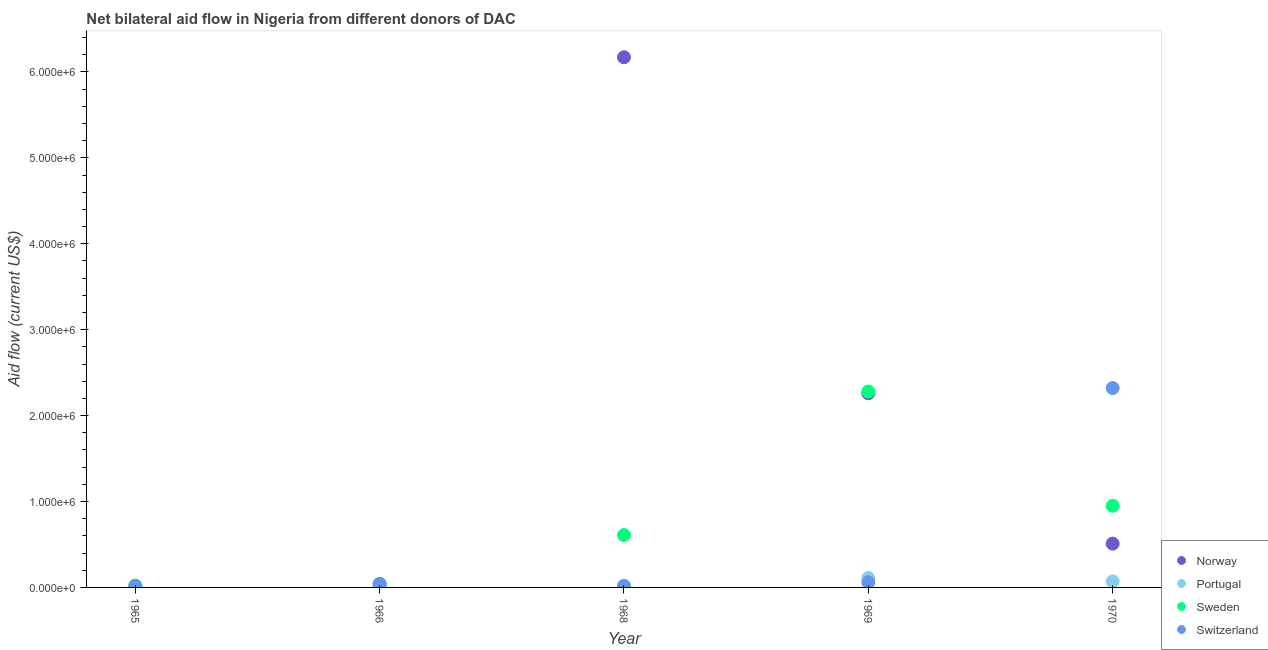How many different coloured dotlines are there?
Make the answer very short. 4. Is the number of dotlines equal to the number of legend labels?
Offer a very short reply. Yes. What is the amount of aid given by norway in 1966?
Give a very brief answer. 4.00e+04. Across all years, what is the maximum amount of aid given by portugal?
Make the answer very short. 1.10e+05. Across all years, what is the minimum amount of aid given by sweden?
Your answer should be compact. 10000. In which year was the amount of aid given by portugal maximum?
Keep it short and to the point. 1969. In which year was the amount of aid given by portugal minimum?
Offer a very short reply. 1965. What is the total amount of aid given by sweden in the graph?
Keep it short and to the point. 3.86e+06. What is the difference between the amount of aid given by portugal in 1969 and that in 1970?
Ensure brevity in your answer.  4.00e+04. What is the difference between the amount of aid given by sweden in 1969 and the amount of aid given by switzerland in 1968?
Keep it short and to the point. 2.26e+06. What is the average amount of aid given by switzerland per year?
Keep it short and to the point. 4.90e+05. In the year 1970, what is the difference between the amount of aid given by norway and amount of aid given by switzerland?
Keep it short and to the point. -1.81e+06. In how many years, is the amount of aid given by sweden greater than 5800000 US$?
Your answer should be very brief. 0. What is the ratio of the amount of aid given by switzerland in 1966 to that in 1969?
Provide a short and direct response. 0.67. Is the amount of aid given by switzerland in 1965 less than that in 1966?
Give a very brief answer. Yes. Is the difference between the amount of aid given by switzerland in 1965 and 1970 greater than the difference between the amount of aid given by norway in 1965 and 1970?
Ensure brevity in your answer.  No. What is the difference between the highest and the second highest amount of aid given by norway?
Your answer should be very brief. 3.91e+06. What is the difference between the highest and the lowest amount of aid given by switzerland?
Give a very brief answer. 2.31e+06. In how many years, is the amount of aid given by sweden greater than the average amount of aid given by sweden taken over all years?
Ensure brevity in your answer.  2. Is the sum of the amount of aid given by portugal in 1965 and 1966 greater than the maximum amount of aid given by sweden across all years?
Keep it short and to the point. No. Is the amount of aid given by switzerland strictly greater than the amount of aid given by norway over the years?
Provide a succinct answer. No. Is the amount of aid given by norway strictly less than the amount of aid given by sweden over the years?
Your response must be concise. No. What is the difference between two consecutive major ticks on the Y-axis?
Make the answer very short. 1.00e+06. Are the values on the major ticks of Y-axis written in scientific E-notation?
Make the answer very short. Yes. Does the graph contain grids?
Offer a terse response. No. Where does the legend appear in the graph?
Give a very brief answer. Bottom right. What is the title of the graph?
Make the answer very short. Net bilateral aid flow in Nigeria from different donors of DAC. What is the Aid flow (current US$) of Portugal in 1965?
Keep it short and to the point. 10000. What is the Aid flow (current US$) in Switzerland in 1965?
Your answer should be compact. 10000. What is the Aid flow (current US$) of Switzerland in 1966?
Make the answer very short. 4.00e+04. What is the Aid flow (current US$) in Norway in 1968?
Provide a succinct answer. 6.17e+06. What is the Aid flow (current US$) of Sweden in 1968?
Keep it short and to the point. 6.10e+05. What is the Aid flow (current US$) of Switzerland in 1968?
Offer a very short reply. 2.00e+04. What is the Aid flow (current US$) in Norway in 1969?
Provide a short and direct response. 2.26e+06. What is the Aid flow (current US$) of Portugal in 1969?
Offer a terse response. 1.10e+05. What is the Aid flow (current US$) in Sweden in 1969?
Offer a terse response. 2.28e+06. What is the Aid flow (current US$) in Norway in 1970?
Your response must be concise. 5.10e+05. What is the Aid flow (current US$) of Sweden in 1970?
Provide a succinct answer. 9.50e+05. What is the Aid flow (current US$) of Switzerland in 1970?
Provide a succinct answer. 2.32e+06. Across all years, what is the maximum Aid flow (current US$) in Norway?
Your answer should be very brief. 6.17e+06. Across all years, what is the maximum Aid flow (current US$) of Portugal?
Provide a short and direct response. 1.10e+05. Across all years, what is the maximum Aid flow (current US$) in Sweden?
Give a very brief answer. 2.28e+06. Across all years, what is the maximum Aid flow (current US$) in Switzerland?
Give a very brief answer. 2.32e+06. Across all years, what is the minimum Aid flow (current US$) of Norway?
Your answer should be very brief. 2.00e+04. What is the total Aid flow (current US$) of Norway in the graph?
Ensure brevity in your answer.  9.00e+06. What is the total Aid flow (current US$) in Sweden in the graph?
Provide a succinct answer. 3.86e+06. What is the total Aid flow (current US$) in Switzerland in the graph?
Offer a terse response. 2.45e+06. What is the difference between the Aid flow (current US$) in Sweden in 1965 and that in 1966?
Make the answer very short. 0. What is the difference between the Aid flow (current US$) of Norway in 1965 and that in 1968?
Provide a succinct answer. -6.15e+06. What is the difference between the Aid flow (current US$) in Portugal in 1965 and that in 1968?
Make the answer very short. 0. What is the difference between the Aid flow (current US$) of Sweden in 1965 and that in 1968?
Keep it short and to the point. -6.00e+05. What is the difference between the Aid flow (current US$) in Switzerland in 1965 and that in 1968?
Offer a terse response. -10000. What is the difference between the Aid flow (current US$) of Norway in 1965 and that in 1969?
Make the answer very short. -2.24e+06. What is the difference between the Aid flow (current US$) in Portugal in 1965 and that in 1969?
Provide a succinct answer. -1.00e+05. What is the difference between the Aid flow (current US$) of Sweden in 1965 and that in 1969?
Your response must be concise. -2.27e+06. What is the difference between the Aid flow (current US$) of Norway in 1965 and that in 1970?
Your response must be concise. -4.90e+05. What is the difference between the Aid flow (current US$) of Sweden in 1965 and that in 1970?
Ensure brevity in your answer.  -9.40e+05. What is the difference between the Aid flow (current US$) of Switzerland in 1965 and that in 1970?
Give a very brief answer. -2.31e+06. What is the difference between the Aid flow (current US$) of Norway in 1966 and that in 1968?
Make the answer very short. -6.13e+06. What is the difference between the Aid flow (current US$) in Sweden in 1966 and that in 1968?
Your answer should be very brief. -6.00e+05. What is the difference between the Aid flow (current US$) of Switzerland in 1966 and that in 1968?
Ensure brevity in your answer.  2.00e+04. What is the difference between the Aid flow (current US$) of Norway in 1966 and that in 1969?
Give a very brief answer. -2.22e+06. What is the difference between the Aid flow (current US$) in Sweden in 1966 and that in 1969?
Offer a terse response. -2.27e+06. What is the difference between the Aid flow (current US$) in Switzerland in 1966 and that in 1969?
Your response must be concise. -2.00e+04. What is the difference between the Aid flow (current US$) in Norway in 1966 and that in 1970?
Make the answer very short. -4.70e+05. What is the difference between the Aid flow (current US$) of Portugal in 1966 and that in 1970?
Your response must be concise. -6.00e+04. What is the difference between the Aid flow (current US$) of Sweden in 1966 and that in 1970?
Offer a very short reply. -9.40e+05. What is the difference between the Aid flow (current US$) in Switzerland in 1966 and that in 1970?
Your answer should be very brief. -2.28e+06. What is the difference between the Aid flow (current US$) in Norway in 1968 and that in 1969?
Provide a short and direct response. 3.91e+06. What is the difference between the Aid flow (current US$) in Sweden in 1968 and that in 1969?
Offer a terse response. -1.67e+06. What is the difference between the Aid flow (current US$) in Switzerland in 1968 and that in 1969?
Provide a short and direct response. -4.00e+04. What is the difference between the Aid flow (current US$) of Norway in 1968 and that in 1970?
Provide a short and direct response. 5.66e+06. What is the difference between the Aid flow (current US$) in Portugal in 1968 and that in 1970?
Keep it short and to the point. -6.00e+04. What is the difference between the Aid flow (current US$) of Switzerland in 1968 and that in 1970?
Offer a very short reply. -2.30e+06. What is the difference between the Aid flow (current US$) of Norway in 1969 and that in 1970?
Make the answer very short. 1.75e+06. What is the difference between the Aid flow (current US$) of Portugal in 1969 and that in 1970?
Your response must be concise. 4.00e+04. What is the difference between the Aid flow (current US$) in Sweden in 1969 and that in 1970?
Give a very brief answer. 1.33e+06. What is the difference between the Aid flow (current US$) of Switzerland in 1969 and that in 1970?
Your answer should be compact. -2.26e+06. What is the difference between the Aid flow (current US$) in Norway in 1965 and the Aid flow (current US$) in Portugal in 1966?
Ensure brevity in your answer.  10000. What is the difference between the Aid flow (current US$) in Norway in 1965 and the Aid flow (current US$) in Switzerland in 1966?
Offer a very short reply. -2.00e+04. What is the difference between the Aid flow (current US$) of Sweden in 1965 and the Aid flow (current US$) of Switzerland in 1966?
Provide a succinct answer. -3.00e+04. What is the difference between the Aid flow (current US$) of Norway in 1965 and the Aid flow (current US$) of Portugal in 1968?
Provide a short and direct response. 10000. What is the difference between the Aid flow (current US$) in Norway in 1965 and the Aid flow (current US$) in Sweden in 1968?
Ensure brevity in your answer.  -5.90e+05. What is the difference between the Aid flow (current US$) of Portugal in 1965 and the Aid flow (current US$) of Sweden in 1968?
Your response must be concise. -6.00e+05. What is the difference between the Aid flow (current US$) of Portugal in 1965 and the Aid flow (current US$) of Switzerland in 1968?
Offer a terse response. -10000. What is the difference between the Aid flow (current US$) of Sweden in 1965 and the Aid flow (current US$) of Switzerland in 1968?
Make the answer very short. -10000. What is the difference between the Aid flow (current US$) in Norway in 1965 and the Aid flow (current US$) in Portugal in 1969?
Your answer should be very brief. -9.00e+04. What is the difference between the Aid flow (current US$) of Norway in 1965 and the Aid flow (current US$) of Sweden in 1969?
Offer a terse response. -2.26e+06. What is the difference between the Aid flow (current US$) in Norway in 1965 and the Aid flow (current US$) in Switzerland in 1969?
Keep it short and to the point. -4.00e+04. What is the difference between the Aid flow (current US$) in Portugal in 1965 and the Aid flow (current US$) in Sweden in 1969?
Offer a very short reply. -2.27e+06. What is the difference between the Aid flow (current US$) in Norway in 1965 and the Aid flow (current US$) in Portugal in 1970?
Offer a terse response. -5.00e+04. What is the difference between the Aid flow (current US$) of Norway in 1965 and the Aid flow (current US$) of Sweden in 1970?
Your response must be concise. -9.30e+05. What is the difference between the Aid flow (current US$) in Norway in 1965 and the Aid flow (current US$) in Switzerland in 1970?
Your answer should be compact. -2.30e+06. What is the difference between the Aid flow (current US$) in Portugal in 1965 and the Aid flow (current US$) in Sweden in 1970?
Make the answer very short. -9.40e+05. What is the difference between the Aid flow (current US$) in Portugal in 1965 and the Aid flow (current US$) in Switzerland in 1970?
Your answer should be compact. -2.31e+06. What is the difference between the Aid flow (current US$) of Sweden in 1965 and the Aid flow (current US$) of Switzerland in 1970?
Give a very brief answer. -2.31e+06. What is the difference between the Aid flow (current US$) of Norway in 1966 and the Aid flow (current US$) of Sweden in 1968?
Your answer should be very brief. -5.70e+05. What is the difference between the Aid flow (current US$) of Portugal in 1966 and the Aid flow (current US$) of Sweden in 1968?
Your answer should be compact. -6.00e+05. What is the difference between the Aid flow (current US$) of Sweden in 1966 and the Aid flow (current US$) of Switzerland in 1968?
Give a very brief answer. -10000. What is the difference between the Aid flow (current US$) of Norway in 1966 and the Aid flow (current US$) of Sweden in 1969?
Offer a terse response. -2.24e+06. What is the difference between the Aid flow (current US$) of Portugal in 1966 and the Aid flow (current US$) of Sweden in 1969?
Provide a short and direct response. -2.27e+06. What is the difference between the Aid flow (current US$) of Sweden in 1966 and the Aid flow (current US$) of Switzerland in 1969?
Your answer should be very brief. -5.00e+04. What is the difference between the Aid flow (current US$) of Norway in 1966 and the Aid flow (current US$) of Sweden in 1970?
Provide a short and direct response. -9.10e+05. What is the difference between the Aid flow (current US$) in Norway in 1966 and the Aid flow (current US$) in Switzerland in 1970?
Keep it short and to the point. -2.28e+06. What is the difference between the Aid flow (current US$) in Portugal in 1966 and the Aid flow (current US$) in Sweden in 1970?
Your response must be concise. -9.40e+05. What is the difference between the Aid flow (current US$) of Portugal in 1966 and the Aid flow (current US$) of Switzerland in 1970?
Ensure brevity in your answer.  -2.31e+06. What is the difference between the Aid flow (current US$) of Sweden in 1966 and the Aid flow (current US$) of Switzerland in 1970?
Provide a short and direct response. -2.31e+06. What is the difference between the Aid flow (current US$) of Norway in 1968 and the Aid flow (current US$) of Portugal in 1969?
Your response must be concise. 6.06e+06. What is the difference between the Aid flow (current US$) of Norway in 1968 and the Aid flow (current US$) of Sweden in 1969?
Ensure brevity in your answer.  3.89e+06. What is the difference between the Aid flow (current US$) in Norway in 1968 and the Aid flow (current US$) in Switzerland in 1969?
Offer a terse response. 6.11e+06. What is the difference between the Aid flow (current US$) in Portugal in 1968 and the Aid flow (current US$) in Sweden in 1969?
Your response must be concise. -2.27e+06. What is the difference between the Aid flow (current US$) in Portugal in 1968 and the Aid flow (current US$) in Switzerland in 1969?
Provide a succinct answer. -5.00e+04. What is the difference between the Aid flow (current US$) in Norway in 1968 and the Aid flow (current US$) in Portugal in 1970?
Make the answer very short. 6.10e+06. What is the difference between the Aid flow (current US$) in Norway in 1968 and the Aid flow (current US$) in Sweden in 1970?
Provide a short and direct response. 5.22e+06. What is the difference between the Aid flow (current US$) in Norway in 1968 and the Aid flow (current US$) in Switzerland in 1970?
Provide a short and direct response. 3.85e+06. What is the difference between the Aid flow (current US$) of Portugal in 1968 and the Aid flow (current US$) of Sweden in 1970?
Ensure brevity in your answer.  -9.40e+05. What is the difference between the Aid flow (current US$) of Portugal in 1968 and the Aid flow (current US$) of Switzerland in 1970?
Provide a succinct answer. -2.31e+06. What is the difference between the Aid flow (current US$) in Sweden in 1968 and the Aid flow (current US$) in Switzerland in 1970?
Give a very brief answer. -1.71e+06. What is the difference between the Aid flow (current US$) in Norway in 1969 and the Aid flow (current US$) in Portugal in 1970?
Provide a short and direct response. 2.19e+06. What is the difference between the Aid flow (current US$) in Norway in 1969 and the Aid flow (current US$) in Sweden in 1970?
Make the answer very short. 1.31e+06. What is the difference between the Aid flow (current US$) in Portugal in 1969 and the Aid flow (current US$) in Sweden in 1970?
Give a very brief answer. -8.40e+05. What is the difference between the Aid flow (current US$) of Portugal in 1969 and the Aid flow (current US$) of Switzerland in 1970?
Give a very brief answer. -2.21e+06. What is the average Aid flow (current US$) of Norway per year?
Your answer should be very brief. 1.80e+06. What is the average Aid flow (current US$) of Portugal per year?
Offer a very short reply. 4.20e+04. What is the average Aid flow (current US$) in Sweden per year?
Give a very brief answer. 7.72e+05. In the year 1965, what is the difference between the Aid flow (current US$) of Norway and Aid flow (current US$) of Portugal?
Keep it short and to the point. 10000. In the year 1965, what is the difference between the Aid flow (current US$) in Portugal and Aid flow (current US$) in Sweden?
Ensure brevity in your answer.  0. In the year 1965, what is the difference between the Aid flow (current US$) in Portugal and Aid flow (current US$) in Switzerland?
Offer a very short reply. 0. In the year 1965, what is the difference between the Aid flow (current US$) in Sweden and Aid flow (current US$) in Switzerland?
Offer a very short reply. 0. In the year 1966, what is the difference between the Aid flow (current US$) in Norway and Aid flow (current US$) in Portugal?
Your answer should be very brief. 3.00e+04. In the year 1966, what is the difference between the Aid flow (current US$) of Norway and Aid flow (current US$) of Sweden?
Your response must be concise. 3.00e+04. In the year 1966, what is the difference between the Aid flow (current US$) of Portugal and Aid flow (current US$) of Sweden?
Offer a very short reply. 0. In the year 1968, what is the difference between the Aid flow (current US$) in Norway and Aid flow (current US$) in Portugal?
Provide a short and direct response. 6.16e+06. In the year 1968, what is the difference between the Aid flow (current US$) in Norway and Aid flow (current US$) in Sweden?
Your answer should be compact. 5.56e+06. In the year 1968, what is the difference between the Aid flow (current US$) in Norway and Aid flow (current US$) in Switzerland?
Offer a very short reply. 6.15e+06. In the year 1968, what is the difference between the Aid flow (current US$) of Portugal and Aid flow (current US$) of Sweden?
Your answer should be very brief. -6.00e+05. In the year 1968, what is the difference between the Aid flow (current US$) in Sweden and Aid flow (current US$) in Switzerland?
Your answer should be compact. 5.90e+05. In the year 1969, what is the difference between the Aid flow (current US$) of Norway and Aid flow (current US$) of Portugal?
Give a very brief answer. 2.15e+06. In the year 1969, what is the difference between the Aid flow (current US$) of Norway and Aid flow (current US$) of Sweden?
Your answer should be compact. -2.00e+04. In the year 1969, what is the difference between the Aid flow (current US$) of Norway and Aid flow (current US$) of Switzerland?
Your answer should be very brief. 2.20e+06. In the year 1969, what is the difference between the Aid flow (current US$) of Portugal and Aid flow (current US$) of Sweden?
Keep it short and to the point. -2.17e+06. In the year 1969, what is the difference between the Aid flow (current US$) of Portugal and Aid flow (current US$) of Switzerland?
Provide a succinct answer. 5.00e+04. In the year 1969, what is the difference between the Aid flow (current US$) in Sweden and Aid flow (current US$) in Switzerland?
Offer a terse response. 2.22e+06. In the year 1970, what is the difference between the Aid flow (current US$) of Norway and Aid flow (current US$) of Sweden?
Keep it short and to the point. -4.40e+05. In the year 1970, what is the difference between the Aid flow (current US$) in Norway and Aid flow (current US$) in Switzerland?
Give a very brief answer. -1.81e+06. In the year 1970, what is the difference between the Aid flow (current US$) in Portugal and Aid flow (current US$) in Sweden?
Offer a terse response. -8.80e+05. In the year 1970, what is the difference between the Aid flow (current US$) in Portugal and Aid flow (current US$) in Switzerland?
Your answer should be very brief. -2.25e+06. In the year 1970, what is the difference between the Aid flow (current US$) of Sweden and Aid flow (current US$) of Switzerland?
Offer a very short reply. -1.37e+06. What is the ratio of the Aid flow (current US$) in Norway in 1965 to that in 1968?
Keep it short and to the point. 0. What is the ratio of the Aid flow (current US$) of Portugal in 1965 to that in 1968?
Offer a terse response. 1. What is the ratio of the Aid flow (current US$) of Sweden in 1965 to that in 1968?
Your answer should be very brief. 0.02. What is the ratio of the Aid flow (current US$) in Norway in 1965 to that in 1969?
Provide a short and direct response. 0.01. What is the ratio of the Aid flow (current US$) of Portugal in 1965 to that in 1969?
Your answer should be compact. 0.09. What is the ratio of the Aid flow (current US$) of Sweden in 1965 to that in 1969?
Provide a succinct answer. 0. What is the ratio of the Aid flow (current US$) of Switzerland in 1965 to that in 1969?
Your answer should be very brief. 0.17. What is the ratio of the Aid flow (current US$) of Norway in 1965 to that in 1970?
Make the answer very short. 0.04. What is the ratio of the Aid flow (current US$) of Portugal in 1965 to that in 1970?
Ensure brevity in your answer.  0.14. What is the ratio of the Aid flow (current US$) in Sweden in 1965 to that in 1970?
Provide a succinct answer. 0.01. What is the ratio of the Aid flow (current US$) of Switzerland in 1965 to that in 1970?
Your answer should be very brief. 0. What is the ratio of the Aid flow (current US$) of Norway in 1966 to that in 1968?
Give a very brief answer. 0.01. What is the ratio of the Aid flow (current US$) of Sweden in 1966 to that in 1968?
Your response must be concise. 0.02. What is the ratio of the Aid flow (current US$) of Norway in 1966 to that in 1969?
Keep it short and to the point. 0.02. What is the ratio of the Aid flow (current US$) of Portugal in 1966 to that in 1969?
Your answer should be compact. 0.09. What is the ratio of the Aid flow (current US$) of Sweden in 1966 to that in 1969?
Make the answer very short. 0. What is the ratio of the Aid flow (current US$) of Norway in 1966 to that in 1970?
Provide a short and direct response. 0.08. What is the ratio of the Aid flow (current US$) of Portugal in 1966 to that in 1970?
Your response must be concise. 0.14. What is the ratio of the Aid flow (current US$) of Sweden in 1966 to that in 1970?
Offer a terse response. 0.01. What is the ratio of the Aid flow (current US$) in Switzerland in 1966 to that in 1970?
Your answer should be compact. 0.02. What is the ratio of the Aid flow (current US$) in Norway in 1968 to that in 1969?
Your response must be concise. 2.73. What is the ratio of the Aid flow (current US$) in Portugal in 1968 to that in 1969?
Give a very brief answer. 0.09. What is the ratio of the Aid flow (current US$) of Sweden in 1968 to that in 1969?
Keep it short and to the point. 0.27. What is the ratio of the Aid flow (current US$) in Switzerland in 1968 to that in 1969?
Offer a terse response. 0.33. What is the ratio of the Aid flow (current US$) in Norway in 1968 to that in 1970?
Offer a very short reply. 12.1. What is the ratio of the Aid flow (current US$) in Portugal in 1968 to that in 1970?
Your answer should be compact. 0.14. What is the ratio of the Aid flow (current US$) of Sweden in 1968 to that in 1970?
Ensure brevity in your answer.  0.64. What is the ratio of the Aid flow (current US$) of Switzerland in 1968 to that in 1970?
Provide a short and direct response. 0.01. What is the ratio of the Aid flow (current US$) of Norway in 1969 to that in 1970?
Your response must be concise. 4.43. What is the ratio of the Aid flow (current US$) in Portugal in 1969 to that in 1970?
Make the answer very short. 1.57. What is the ratio of the Aid flow (current US$) of Sweden in 1969 to that in 1970?
Make the answer very short. 2.4. What is the ratio of the Aid flow (current US$) in Switzerland in 1969 to that in 1970?
Keep it short and to the point. 0.03. What is the difference between the highest and the second highest Aid flow (current US$) in Norway?
Make the answer very short. 3.91e+06. What is the difference between the highest and the second highest Aid flow (current US$) in Sweden?
Provide a succinct answer. 1.33e+06. What is the difference between the highest and the second highest Aid flow (current US$) of Switzerland?
Make the answer very short. 2.26e+06. What is the difference between the highest and the lowest Aid flow (current US$) in Norway?
Give a very brief answer. 6.15e+06. What is the difference between the highest and the lowest Aid flow (current US$) of Portugal?
Keep it short and to the point. 1.00e+05. What is the difference between the highest and the lowest Aid flow (current US$) in Sweden?
Make the answer very short. 2.27e+06. What is the difference between the highest and the lowest Aid flow (current US$) in Switzerland?
Your answer should be compact. 2.31e+06. 